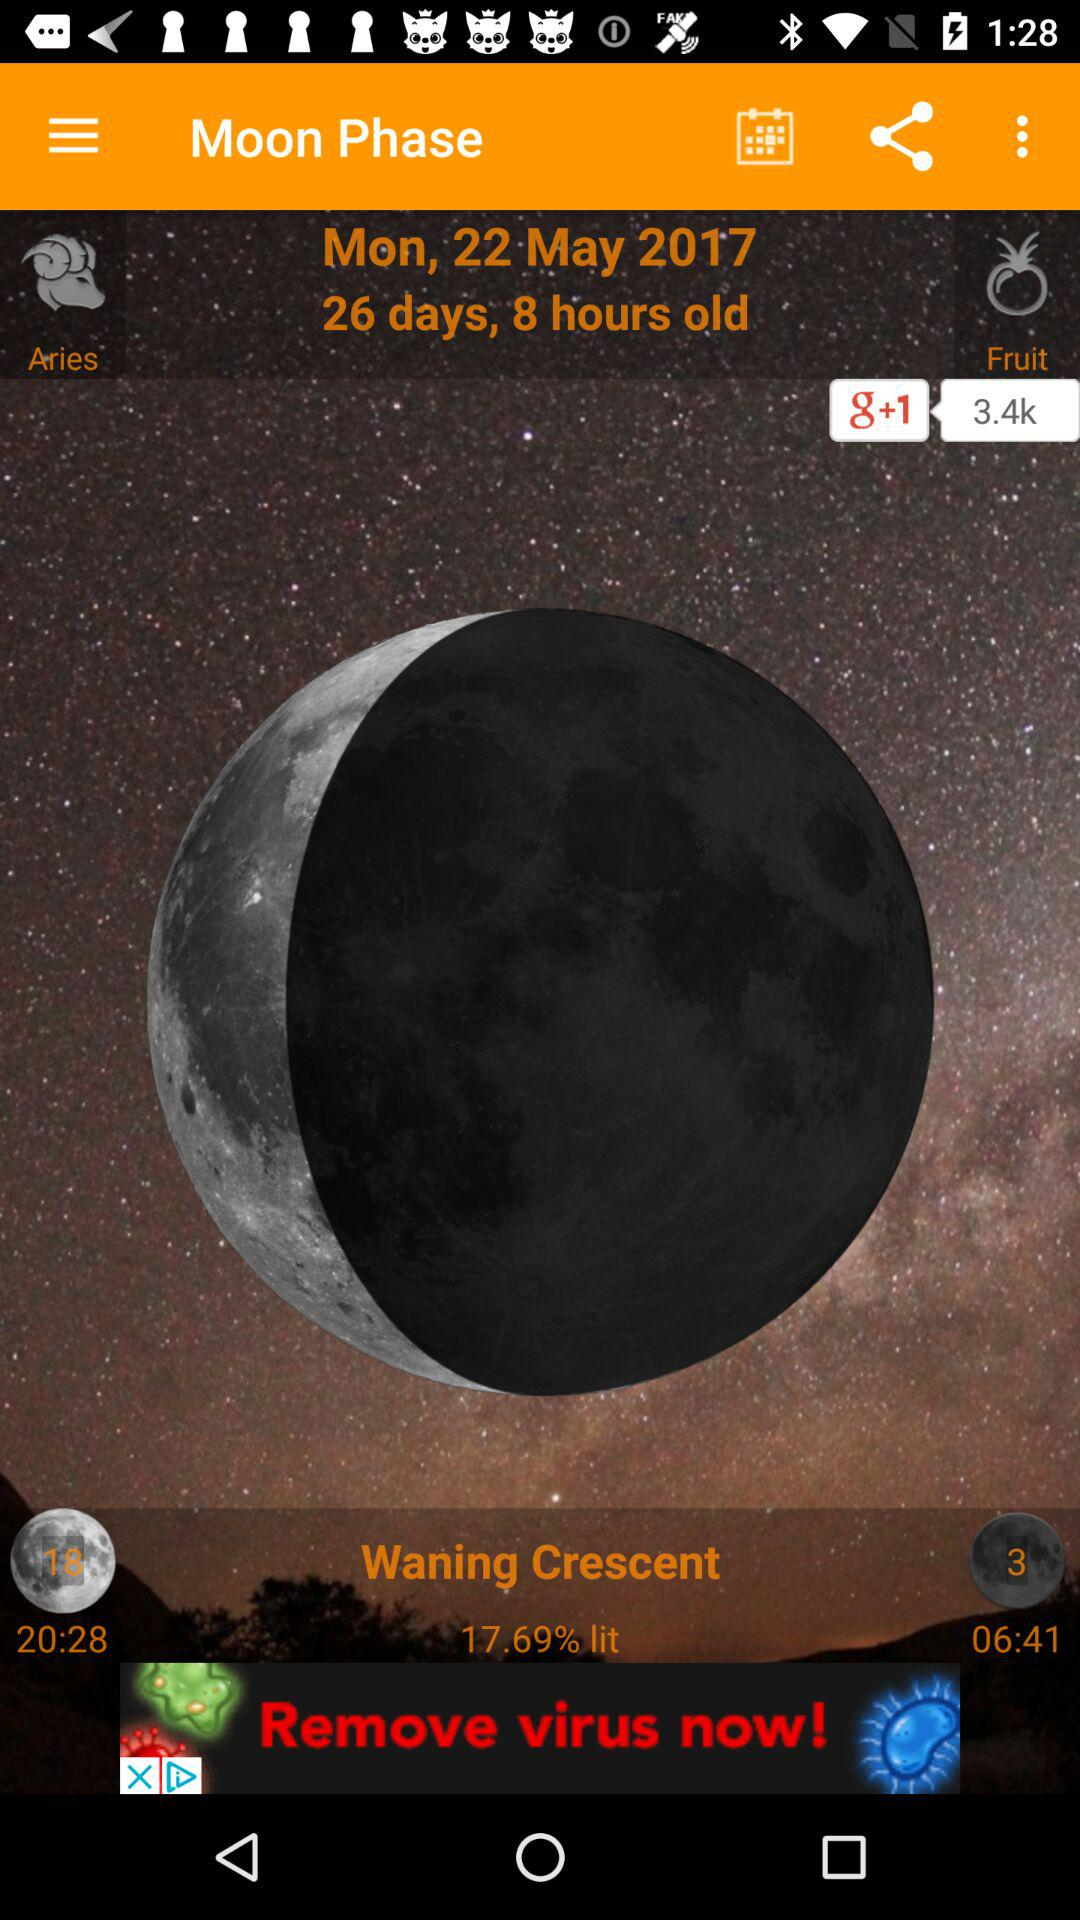What is the day of the week on May 22? The day is Monday. 